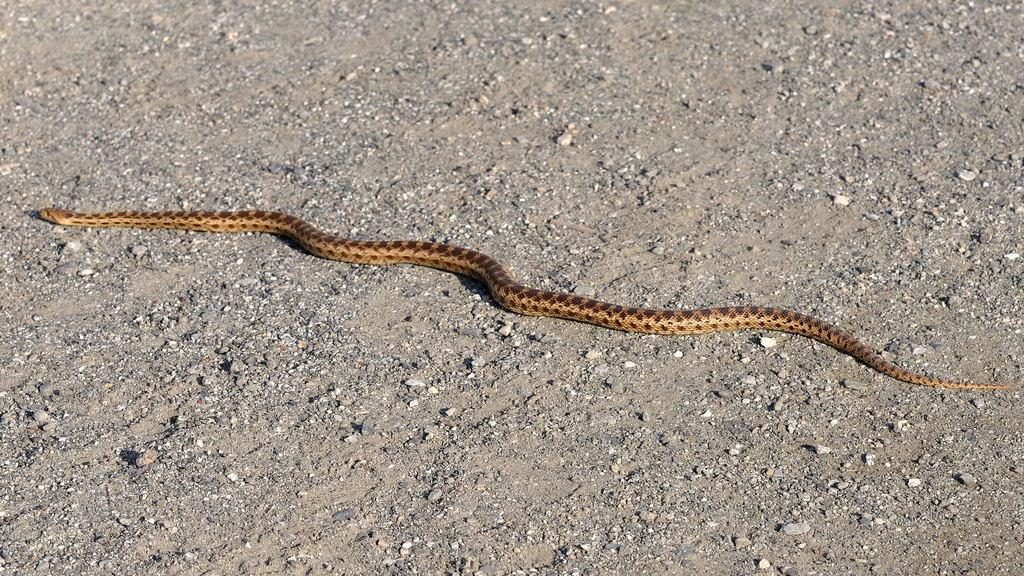What type of animal is in the image? There is a snake in the image. Can you describe the color pattern of the snake? The snake has brown and cream colors. What else can be seen in the image besides the snake? There are stones visible in the image. How many members are on the team in the image? There is no team present in the image; it features a snake and stones. What type of structure can be seen in the corner of the image? There is no structure, such as a cobweb or spring, present in the image. 